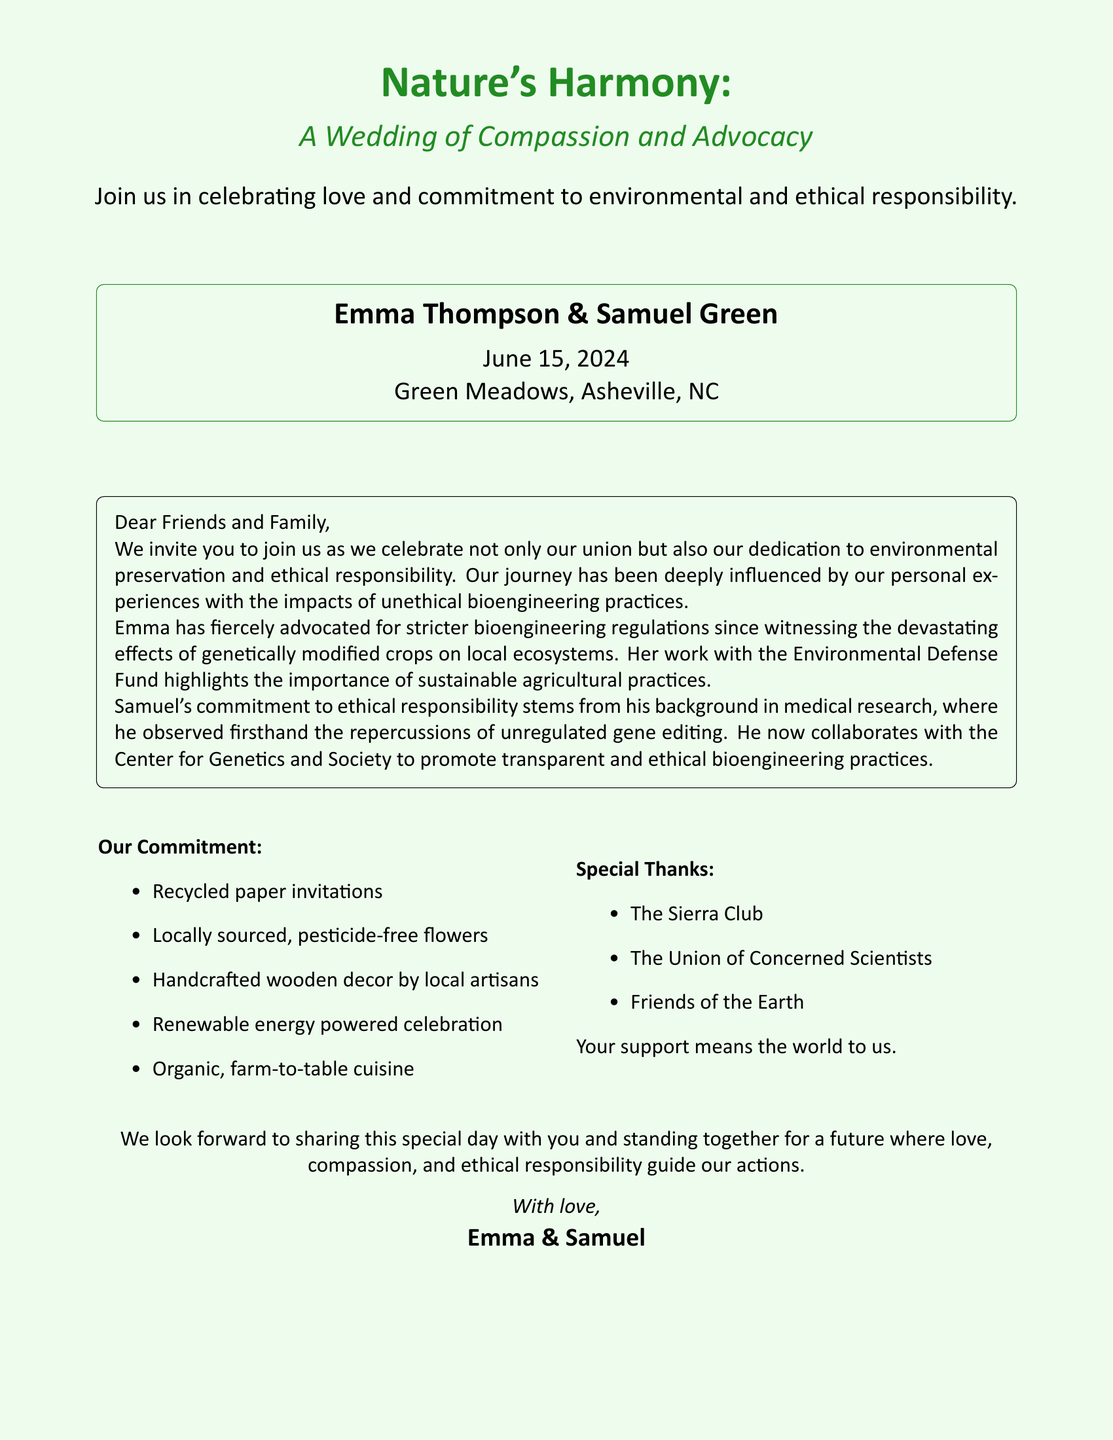what are the names of the couple? The invitation states the names of the couple as Emma Thompson and Samuel Green.
Answer: Emma Thompson & Samuel Green what is the date of the wedding? The document explicitly mentions the date of the wedding as June 15, 2024.
Answer: June 15, 2024 where is the wedding taking place? The location for the wedding is specified in the document as Green Meadows, Asheville, NC.
Answer: Green Meadows, Asheville, NC what type of paper is used for the invitations? The invitation mentions that the invitations are made from recycled paper.
Answer: Recycled paper who is Emma advocating for? Emma advocates for stricter bioengineering regulations, particularly through her work with the Environmental Defense Fund.
Answer: Environmental Defense Fund which organization does Samuel collaborate with? Samuel is noted to collaborate with the Center for Genetics and Society in promoting ethical bioengineering practices.
Answer: Center for Genetics and Society what kind of cuisine will be served? The invitation specifies that the cuisine will be organic, farm-to-table.
Answer: Organic, farm-to-table which color is used for the text title? The main title text color on the invitation is nature green.
Answer: nature green what is the invitation’s theme? The invitation emphasizes a theme of environmental and ethical responsibility.
Answer: Environmental and ethical responsibility 